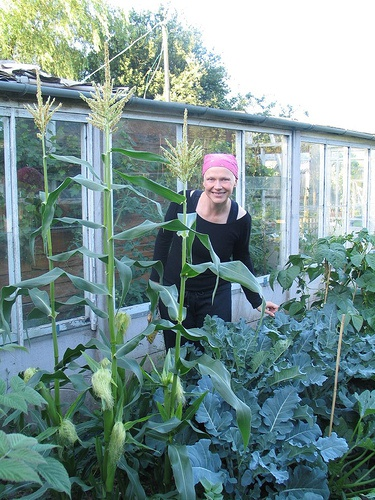Describe the objects in this image and their specific colors. I can see people in white, black, navy, teal, and lavender tones in this image. 